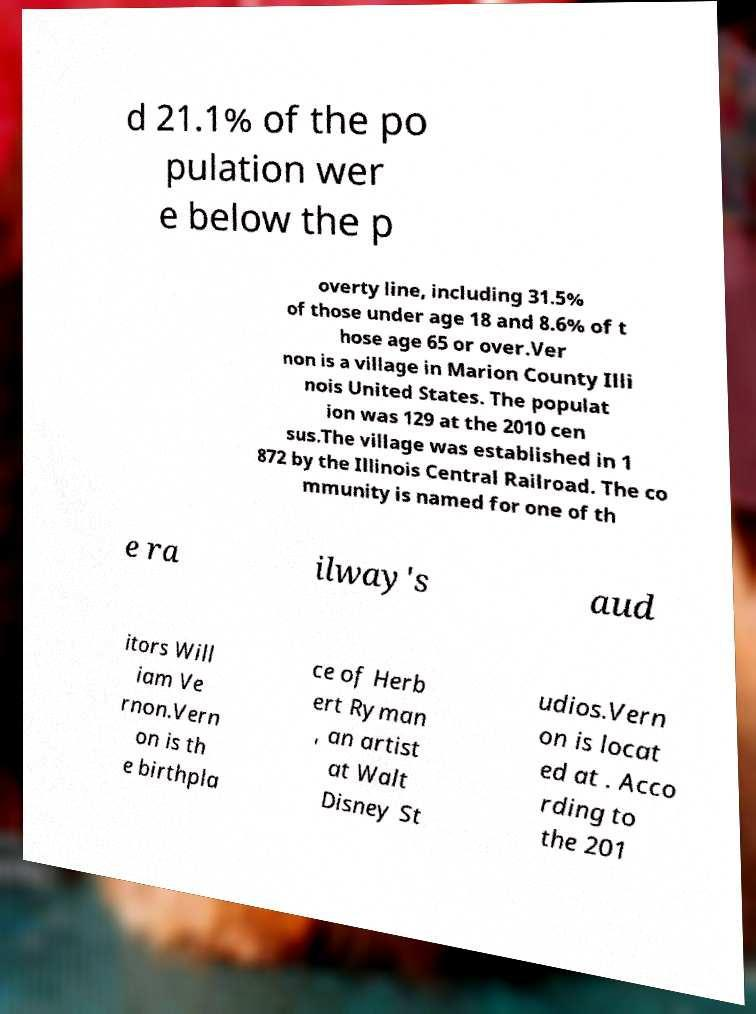Please read and relay the text visible in this image. What does it say? d 21.1% of the po pulation wer e below the p overty line, including 31.5% of those under age 18 and 8.6% of t hose age 65 or over.Ver non is a village in Marion County Illi nois United States. The populat ion was 129 at the 2010 cen sus.The village was established in 1 872 by the Illinois Central Railroad. The co mmunity is named for one of th e ra ilway's aud itors Will iam Ve rnon.Vern on is th e birthpla ce of Herb ert Ryman , an artist at Walt Disney St udios.Vern on is locat ed at . Acco rding to the 201 